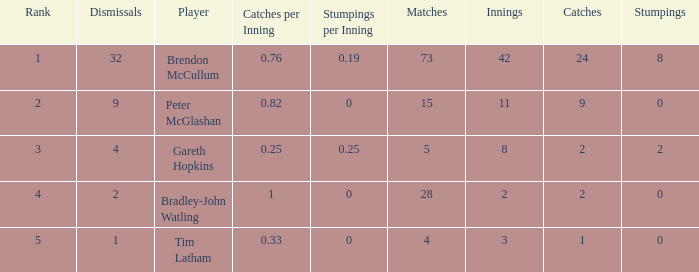How many stumpings did the player Tim Latham have? 0.0. 